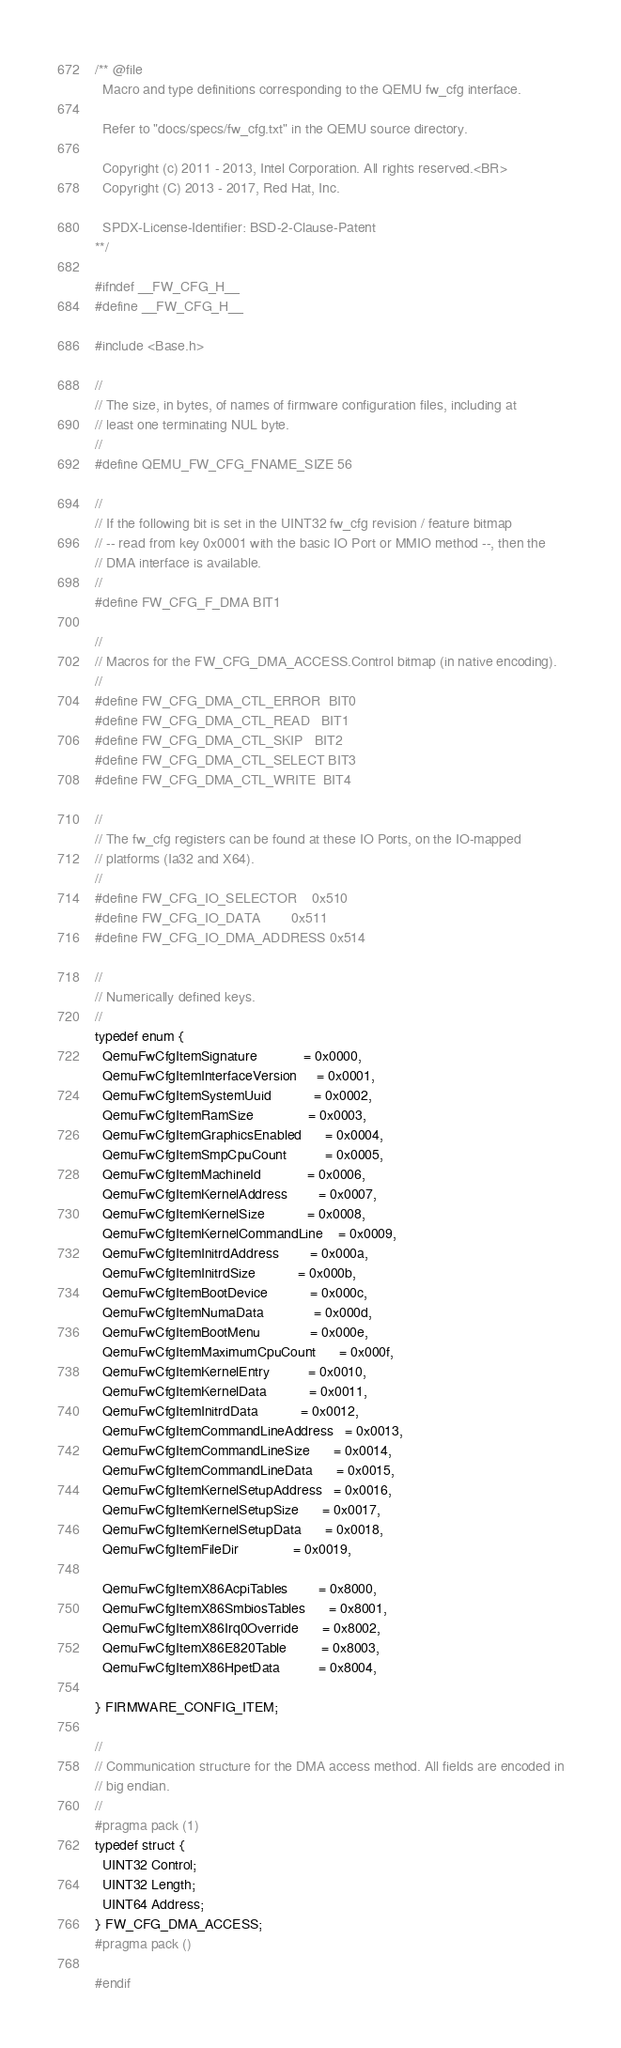Convert code to text. <code><loc_0><loc_0><loc_500><loc_500><_C_>/** @file
  Macro and type definitions corresponding to the QEMU fw_cfg interface.

  Refer to "docs/specs/fw_cfg.txt" in the QEMU source directory.

  Copyright (c) 2011 - 2013, Intel Corporation. All rights reserved.<BR>
  Copyright (C) 2013 - 2017, Red Hat, Inc.

  SPDX-License-Identifier: BSD-2-Clause-Patent
**/

#ifndef __FW_CFG_H__
#define __FW_CFG_H__

#include <Base.h>

//
// The size, in bytes, of names of firmware configuration files, including at
// least one terminating NUL byte.
//
#define QEMU_FW_CFG_FNAME_SIZE 56

//
// If the following bit is set in the UINT32 fw_cfg revision / feature bitmap
// -- read from key 0x0001 with the basic IO Port or MMIO method --, then the
// DMA interface is available.
//
#define FW_CFG_F_DMA BIT1

//
// Macros for the FW_CFG_DMA_ACCESS.Control bitmap (in native encoding).
//
#define FW_CFG_DMA_CTL_ERROR  BIT0
#define FW_CFG_DMA_CTL_READ   BIT1
#define FW_CFG_DMA_CTL_SKIP   BIT2
#define FW_CFG_DMA_CTL_SELECT BIT3
#define FW_CFG_DMA_CTL_WRITE  BIT4

//
// The fw_cfg registers can be found at these IO Ports, on the IO-mapped
// platforms (Ia32 and X64).
//
#define FW_CFG_IO_SELECTOR    0x510
#define FW_CFG_IO_DATA        0x511
#define FW_CFG_IO_DMA_ADDRESS 0x514

//
// Numerically defined keys.
//
typedef enum {
  QemuFwCfgItemSignature            = 0x0000,
  QemuFwCfgItemInterfaceVersion     = 0x0001,
  QemuFwCfgItemSystemUuid           = 0x0002,
  QemuFwCfgItemRamSize              = 0x0003,
  QemuFwCfgItemGraphicsEnabled      = 0x0004,
  QemuFwCfgItemSmpCpuCount          = 0x0005,
  QemuFwCfgItemMachineId            = 0x0006,
  QemuFwCfgItemKernelAddress        = 0x0007,
  QemuFwCfgItemKernelSize           = 0x0008,
  QemuFwCfgItemKernelCommandLine    = 0x0009,
  QemuFwCfgItemInitrdAddress        = 0x000a,
  QemuFwCfgItemInitrdSize           = 0x000b,
  QemuFwCfgItemBootDevice           = 0x000c,
  QemuFwCfgItemNumaData             = 0x000d,
  QemuFwCfgItemBootMenu             = 0x000e,
  QemuFwCfgItemMaximumCpuCount      = 0x000f,
  QemuFwCfgItemKernelEntry          = 0x0010,
  QemuFwCfgItemKernelData           = 0x0011,
  QemuFwCfgItemInitrdData           = 0x0012,
  QemuFwCfgItemCommandLineAddress   = 0x0013,
  QemuFwCfgItemCommandLineSize      = 0x0014,
  QemuFwCfgItemCommandLineData      = 0x0015,
  QemuFwCfgItemKernelSetupAddress   = 0x0016,
  QemuFwCfgItemKernelSetupSize      = 0x0017,
  QemuFwCfgItemKernelSetupData      = 0x0018,
  QemuFwCfgItemFileDir              = 0x0019,

  QemuFwCfgItemX86AcpiTables        = 0x8000,
  QemuFwCfgItemX86SmbiosTables      = 0x8001,
  QemuFwCfgItemX86Irq0Override      = 0x8002,
  QemuFwCfgItemX86E820Table         = 0x8003,
  QemuFwCfgItemX86HpetData          = 0x8004,

} FIRMWARE_CONFIG_ITEM;

//
// Communication structure for the DMA access method. All fields are encoded in
// big endian.
//
#pragma pack (1)
typedef struct {
  UINT32 Control;
  UINT32 Length;
  UINT64 Address;
} FW_CFG_DMA_ACCESS;
#pragma pack ()

#endif
</code> 